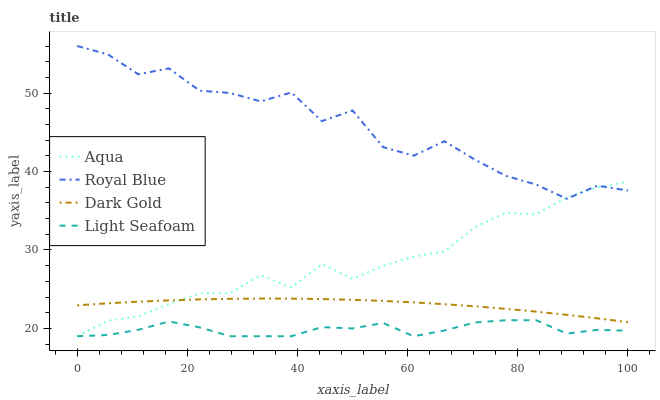Does Light Seafoam have the minimum area under the curve?
Answer yes or no. Yes. Does Royal Blue have the maximum area under the curve?
Answer yes or no. Yes. Does Aqua have the minimum area under the curve?
Answer yes or no. No. Does Aqua have the maximum area under the curve?
Answer yes or no. No. Is Dark Gold the smoothest?
Answer yes or no. Yes. Is Royal Blue the roughest?
Answer yes or no. Yes. Is Light Seafoam the smoothest?
Answer yes or no. No. Is Light Seafoam the roughest?
Answer yes or no. No. Does Light Seafoam have the lowest value?
Answer yes or no. Yes. Does Dark Gold have the lowest value?
Answer yes or no. No. Does Royal Blue have the highest value?
Answer yes or no. Yes. Does Aqua have the highest value?
Answer yes or no. No. Is Light Seafoam less than Dark Gold?
Answer yes or no. Yes. Is Dark Gold greater than Light Seafoam?
Answer yes or no. Yes. Does Aqua intersect Light Seafoam?
Answer yes or no. Yes. Is Aqua less than Light Seafoam?
Answer yes or no. No. Is Aqua greater than Light Seafoam?
Answer yes or no. No. Does Light Seafoam intersect Dark Gold?
Answer yes or no. No. 